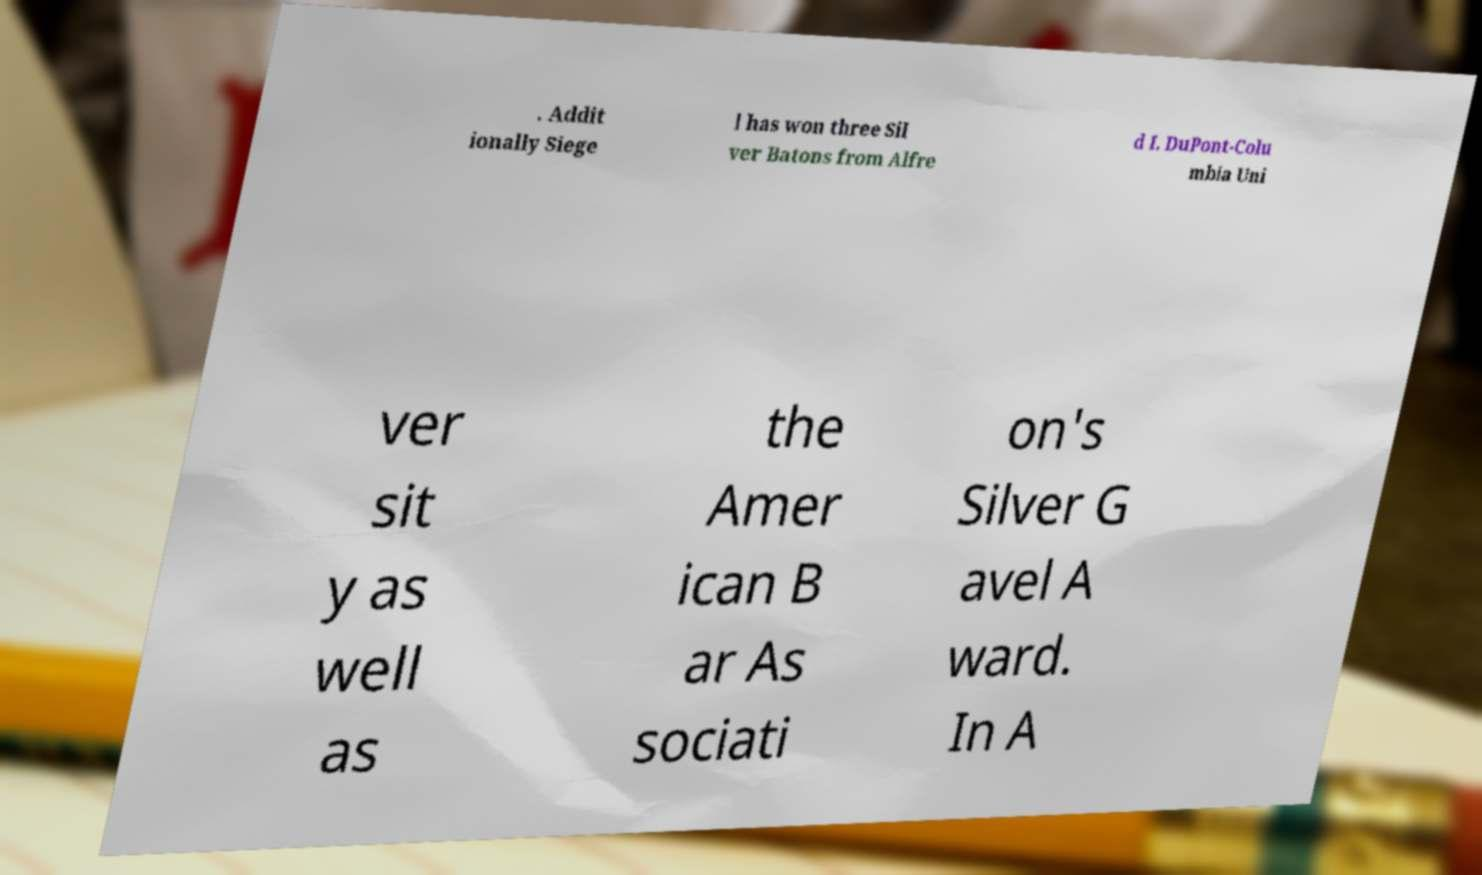I need the written content from this picture converted into text. Can you do that? . Addit ionally Siege l has won three Sil ver Batons from Alfre d I. DuPont-Colu mbia Uni ver sit y as well as the Amer ican B ar As sociati on's Silver G avel A ward. In A 